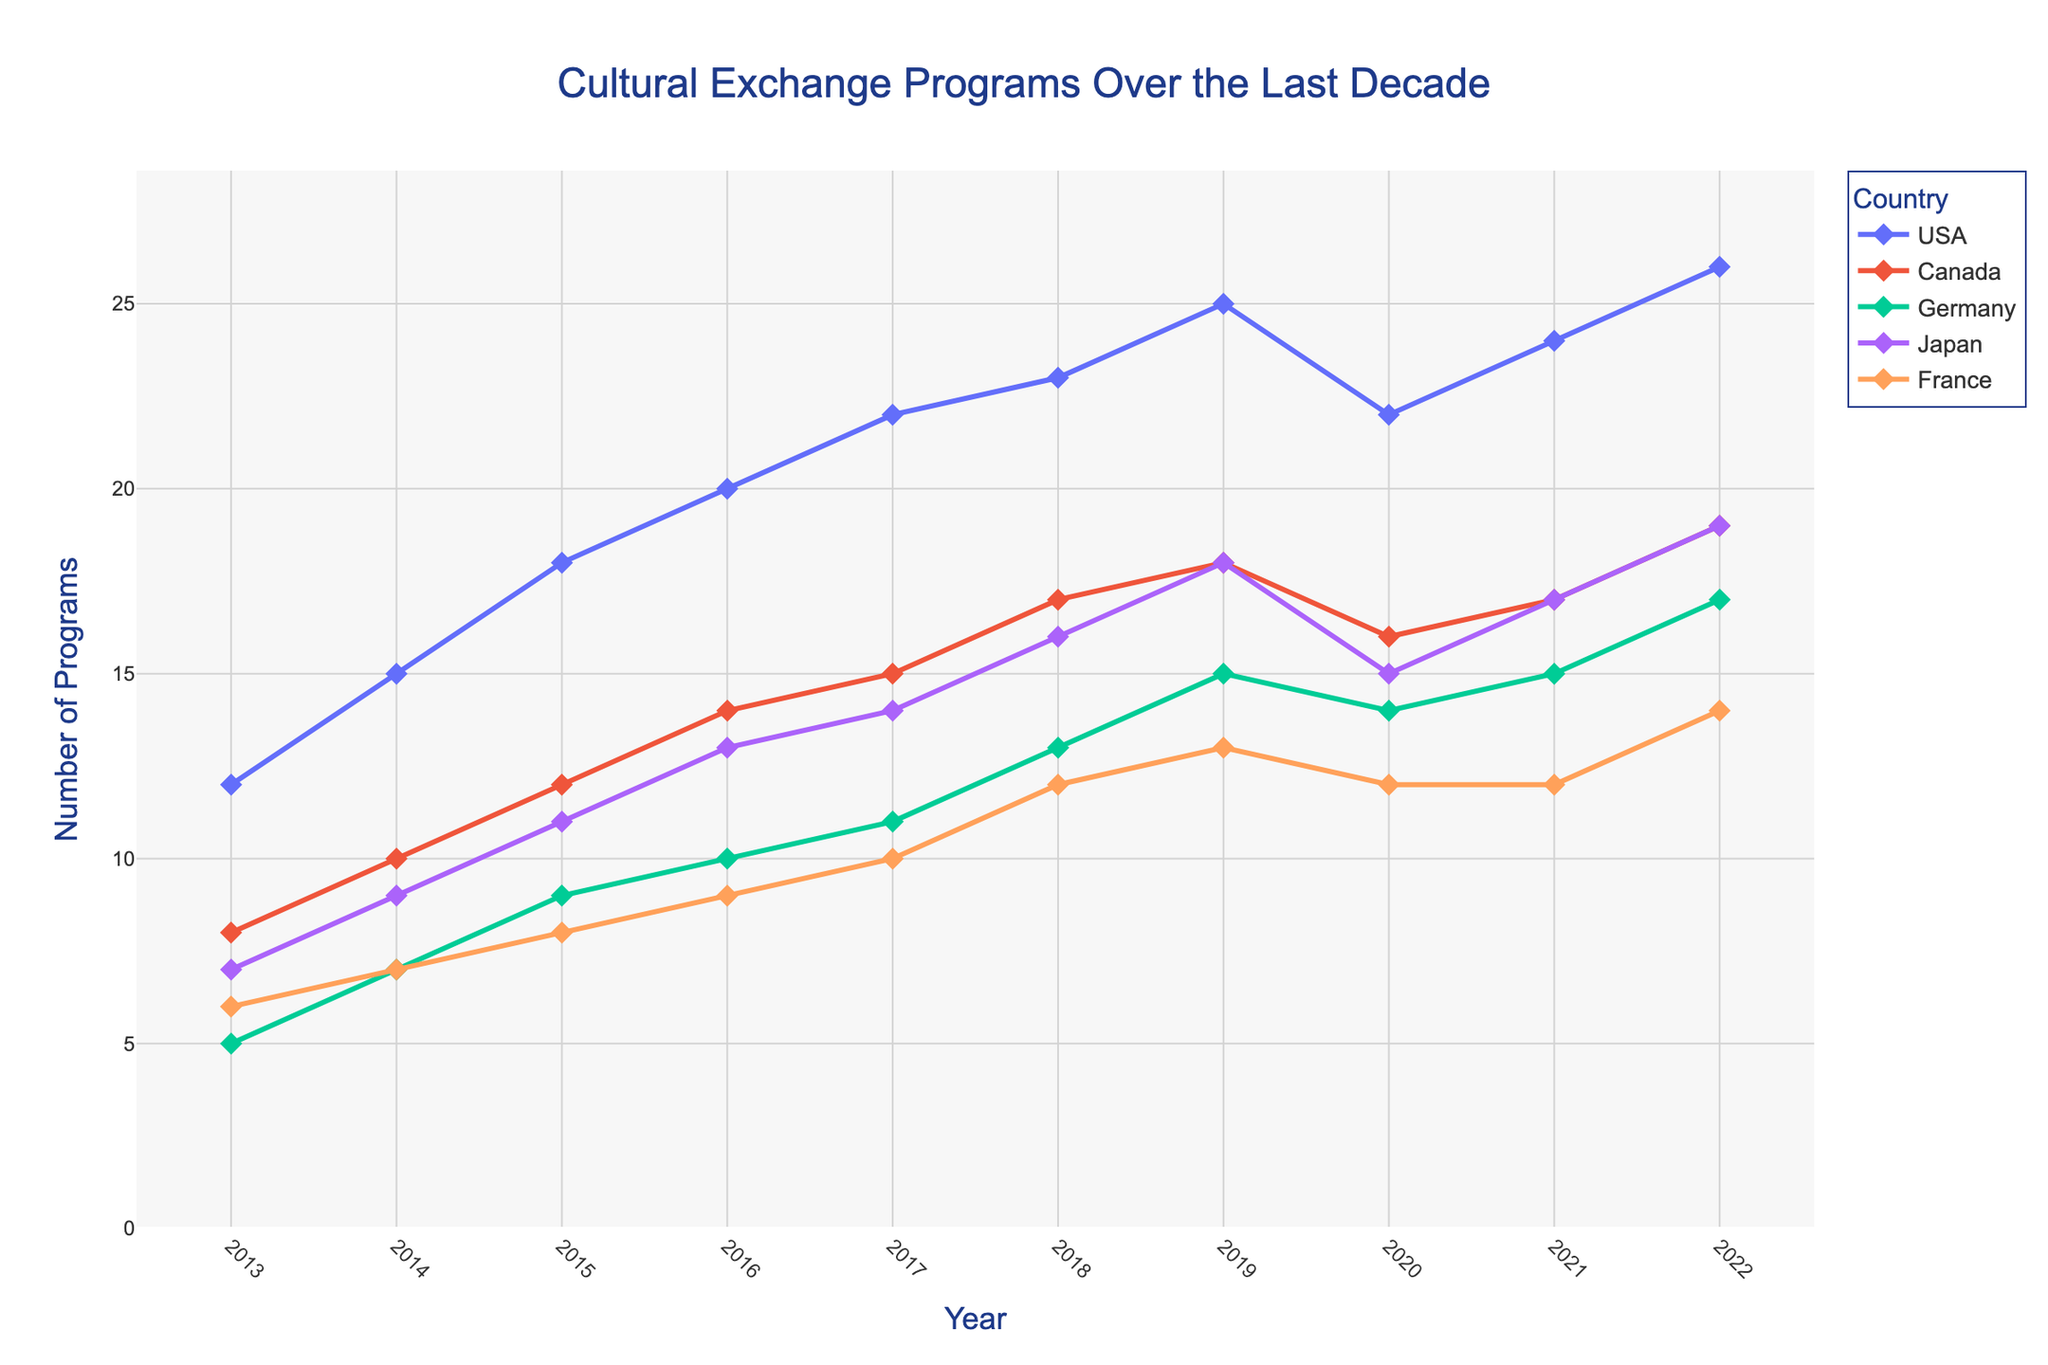What is the title of the figure? The title of the figure is usually displayed prominently above the plot.
Answer: Cultural Exchange Programs Over the Last Decade How many countries are represented in the plot? Count the number of unique country traces in the figure legend or lines with different markers/colors.
Answer: 5 Which country had the highest number of cultural exchange programs in 2022? Look at the data points for the year 2022 and compare the values associated with each country.
Answer: USA Which year shows the highest number of cultural exchange programs for France? Find the peak point in the line or marker for France, and note the corresponding year.
Answer: 2022 Between which years did the number of cultural exchange programs with Japan increase the most? Observe the changes in the line/markers for Japan and find the pair of consecutive years with the largest increase.
Answer: 2019-2020 How did the number of cultural exchange programs between the USA and [Your Country] change from 2013 to 2022? Find the 2013 and 2022 data points for the USA and calculate the difference.
Answer: Increased by 14 Which country experienced a decrease in the number of cultural exchange programs in 2020 compared to 2019? Compare the data points between 2019 and 2020 for all countries and identify decreases.
Answer: USA and Canada What is the average number of cultural exchange programs for Germany over the decade? Add all the yearly data points for Germany and divide by the number of years (10).
Answer: 11.1 Which country has the most consistent number of cultural exchange programs over the years? Observe the trend lines and assess which country shows the least fluctuation.
Answer: Germany In which year was the combined number of cultural exchange programs for all countries the lowest? Sum the number of exchange programs for all countries in each year, and identify the year with the smallest total.
Answer: 2013 